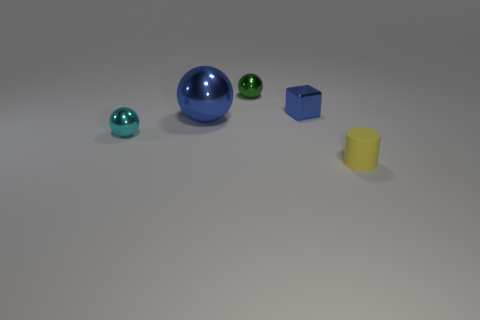Subtract all tiny cyan metallic balls. How many balls are left? 2 Add 1 small cyan rubber cubes. How many objects exist? 6 Subtract 3 balls. How many balls are left? 0 Subtract all blue balls. How many balls are left? 2 Subtract all gray cubes. Subtract all yellow balls. How many cubes are left? 1 Subtract all cyan cylinders. How many yellow cubes are left? 0 Subtract all green things. Subtract all shiny balls. How many objects are left? 1 Add 3 green balls. How many green balls are left? 4 Add 2 small blue things. How many small blue things exist? 3 Subtract 0 yellow balls. How many objects are left? 5 